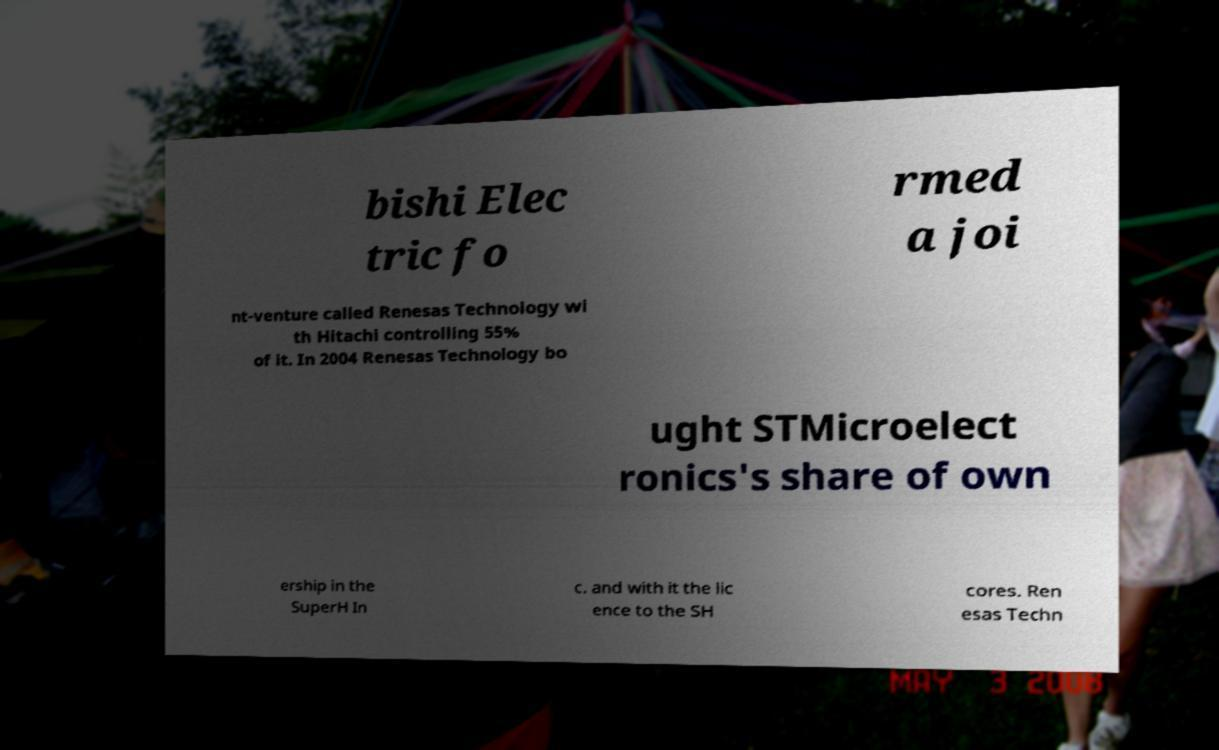Can you accurately transcribe the text from the provided image for me? bishi Elec tric fo rmed a joi nt-venture called Renesas Technology wi th Hitachi controlling 55% of it. In 2004 Renesas Technology bo ught STMicroelect ronics's share of own ership in the SuperH In c. and with it the lic ence to the SH cores. Ren esas Techn 